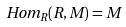Convert formula to latex. <formula><loc_0><loc_0><loc_500><loc_500>H o m _ { R } ( R , M ) = M</formula> 